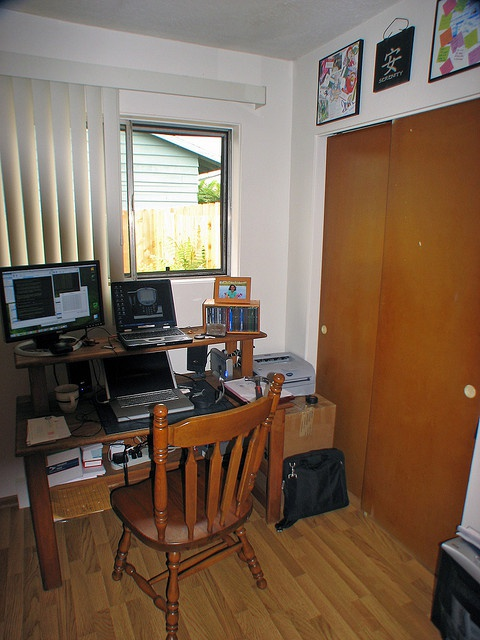Describe the objects in this image and their specific colors. I can see chair in black, maroon, and brown tones, tv in black and gray tones, laptop in black, gray, darkgray, and maroon tones, laptop in black, gray, and darkgray tones, and tv in black, gray, navy, and darkblue tones in this image. 